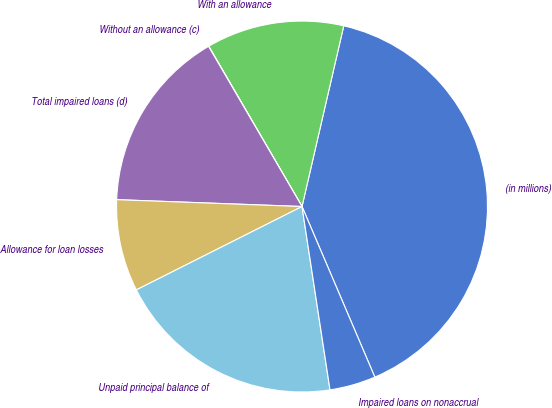Convert chart. <chart><loc_0><loc_0><loc_500><loc_500><pie_chart><fcel>(in millions)<fcel>With an allowance<fcel>Without an allowance (c)<fcel>Total impaired loans (d)<fcel>Allowance for loan losses<fcel>Unpaid principal balance of<fcel>Impaired loans on nonaccrual<nl><fcel>39.96%<fcel>12.0%<fcel>0.02%<fcel>16.0%<fcel>8.01%<fcel>19.99%<fcel>4.01%<nl></chart> 